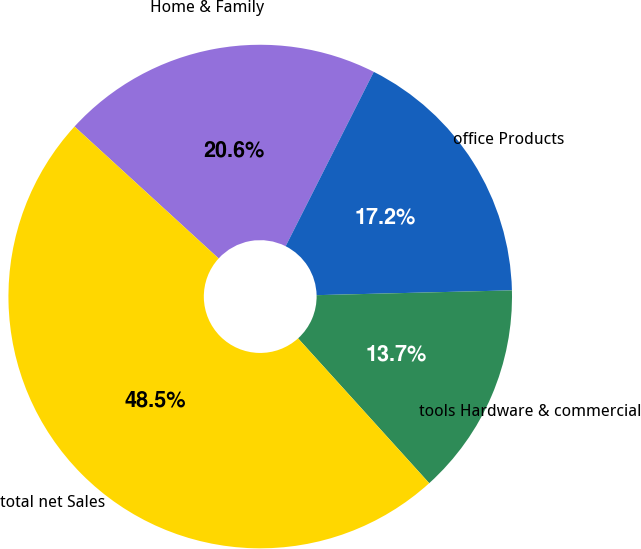<chart> <loc_0><loc_0><loc_500><loc_500><pie_chart><fcel>Home & Family<fcel>office Products<fcel>tools Hardware & commercial<fcel>total net Sales<nl><fcel>20.65%<fcel>17.16%<fcel>13.68%<fcel>48.51%<nl></chart> 